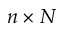<formula> <loc_0><loc_0><loc_500><loc_500>n \times N</formula> 